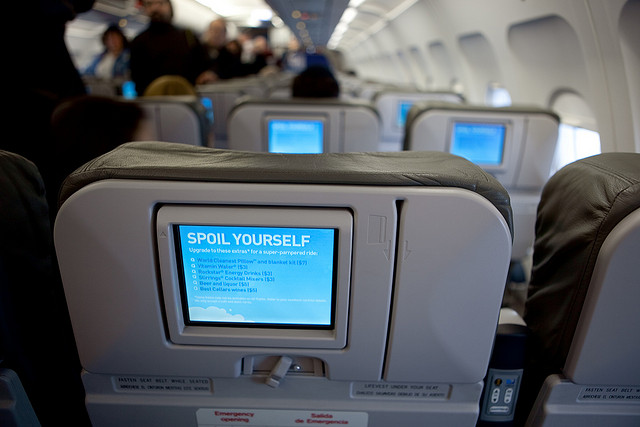Read and extract the text from this image. SPOIL YOURSELF Upgrade 